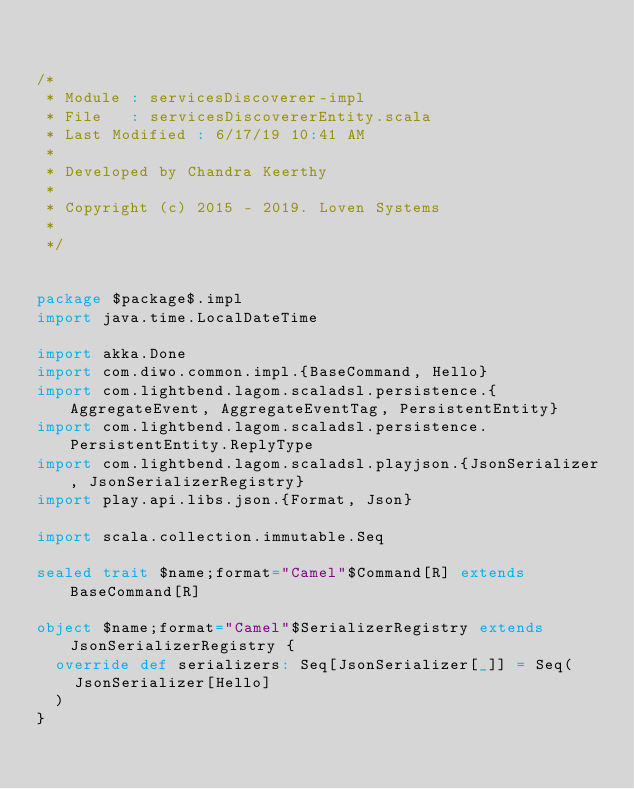<code> <loc_0><loc_0><loc_500><loc_500><_Scala_>

/*
 * Module : servicesDiscoverer-impl
 * File   : servicesDiscovererEntity.scala
 * Last Modified : 6/17/19 10:41 AM
 *
 * Developed by Chandra Keerthy
 *
 * Copyright (c) 2015 - 2019. Loven Systems
 *
 */


package $package$.impl
import java.time.LocalDateTime

import akka.Done
import com.diwo.common.impl.{BaseCommand, Hello}
import com.lightbend.lagom.scaladsl.persistence.{AggregateEvent, AggregateEventTag, PersistentEntity}
import com.lightbend.lagom.scaladsl.persistence.PersistentEntity.ReplyType
import com.lightbend.lagom.scaladsl.playjson.{JsonSerializer, JsonSerializerRegistry}
import play.api.libs.json.{Format, Json}

import scala.collection.immutable.Seq

sealed trait $name;format="Camel"$Command[R] extends BaseCommand[R]

object $name;format="Camel"$SerializerRegistry extends JsonSerializerRegistry {
  override def serializers: Seq[JsonSerializer[_]] = Seq(
    JsonSerializer[Hello]
  )
}
</code> 